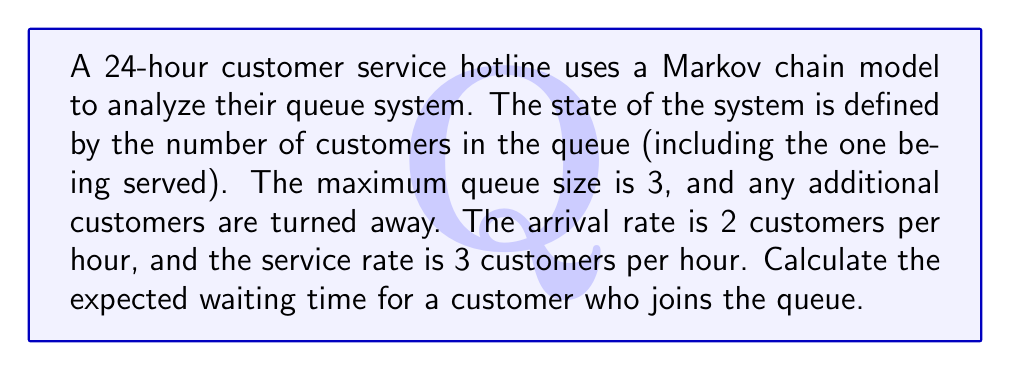Help me with this question. Let's approach this step-by-step:

1) First, we need to set up the transition rate matrix $Q$ for the Markov chain:

   $$Q = \begin{bmatrix}
   -2 & 2 & 0 & 0 \\
   3 & -5 & 2 & 0 \\
   0 & 3 & -5 & 2 \\
   0 & 0 & 3 & -3
   \end{bmatrix}$$

2) To find the steady-state probabilities, we solve the equation $\pi Q = 0$ along with $\sum_{i=0}^3 \pi_i = 1$:

   $$\begin{aligned}
   -2\pi_0 + 3\pi_1 &= 0 \\
   2\pi_0 - 5\pi_1 + 3\pi_2 &= 0 \\
   2\pi_1 - 5\pi_2 + 3\pi_3 &= 0 \\
   2\pi_2 - 3\pi_3 &= 0 \\
   \pi_0 + \pi_1 + \pi_2 + \pi_3 &= 1
   \end{aligned}$$

3) Solving this system of equations gives:

   $$\pi_0 = \frac{9}{19}, \pi_1 = \frac{6}{19}, \pi_2 = \frac{3}{19}, \pi_3 = \frac{1}{19}$$

4) The probability that an arriving customer joins the queue is:

   $$P(\text{join}) = \pi_0 + \pi_1 + \pi_2 = \frac{18}{19}$$

5) The expected number of customers in the system, given that a new customer joins, is:

   $$E[N|\text{join}] = \frac{\pi_1 \cdot 1 + \pi_2 \cdot 2 + \pi_3 \cdot 3}{\pi_0 + \pi_1 + \pi_2} = \frac{15}{18} = \frac{5}{6}$$

6) By Little's Law, the expected waiting time $W$ is:

   $$W = \frac{E[N|\text{join}]}{\lambda_{\text{eff}}}$$

   where $\lambda_{\text{eff}}$ is the effective arrival rate:

   $$\lambda_{\text{eff}} = \lambda \cdot P(\text{join}) = 2 \cdot \frac{18}{19} = \frac{36}{19}$$

7) Therefore, the expected waiting time is:

   $$W = \frac{5/6}{36/19} = \frac{95}{216} \approx 0.44 \text{ hours}$$
Answer: $\frac{95}{216}$ hours or approximately 0.44 hours 